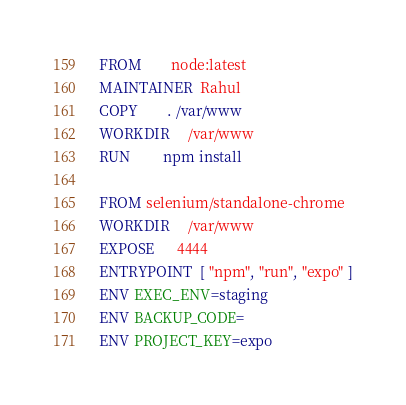Convert code to text. <code><loc_0><loc_0><loc_500><loc_500><_Dockerfile_>FROM        node:latest
MAINTAINER  Rahul
COPY        . /var/www
WORKDIR     /var/www
RUN         npm install

FROM selenium/standalone-chrome
WORKDIR     /var/www
EXPOSE      4444
ENTRYPOINT  [ "npm", "run", "expo" ]
ENV EXEC_ENV=staging
ENV BACKUP_CODE=
ENV PROJECT_KEY=expo</code> 